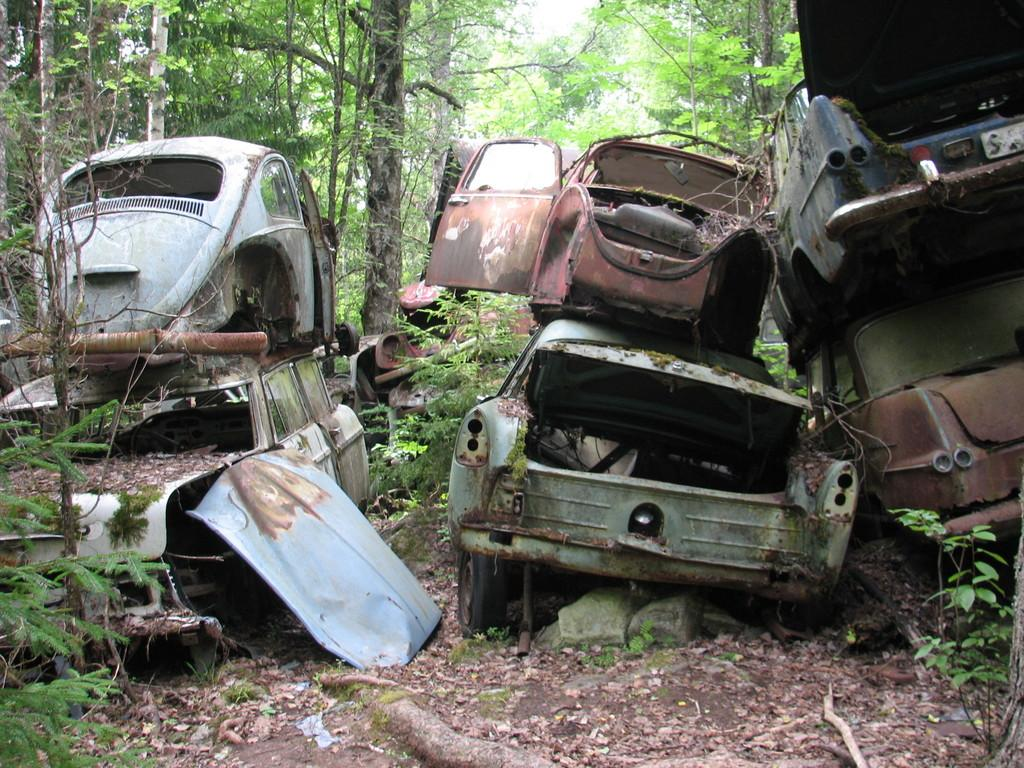What types of objects are on the ground in the image? There are vehicles on the ground in the image. What type of natural elements can be seen in the image? There are trees in the image. What is visible above the ground in the image? The sky is visible in the image. What language are the vehicles speaking to each other in the image? Vehicles do not speak languages; they are inanimate objects. Can you see a flock of birds in the image? There is no mention of birds or a flock in the provided facts, so we cannot determine if they are present in the image. 